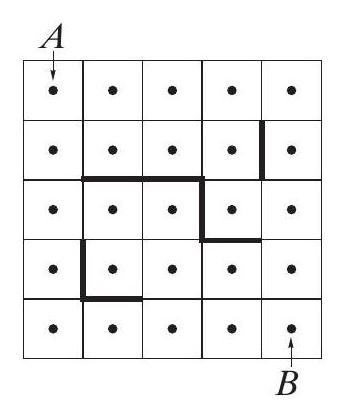What strategies could be used to solve the pathfinding challenge illustrated in the image, considering the obstacles? To solve the pathfinding challenge in the grid, one effective strategy is to use algorithms like A* or Dijkstra's Algorithm, which are well-suited for finding shortest paths in weighted grids. These algorithms can be adapted to consider blocked paths as having infinite weight. Visualization or computational tools can also help simulate various paths and dynamically adjust routes as obstacles are encountered. 